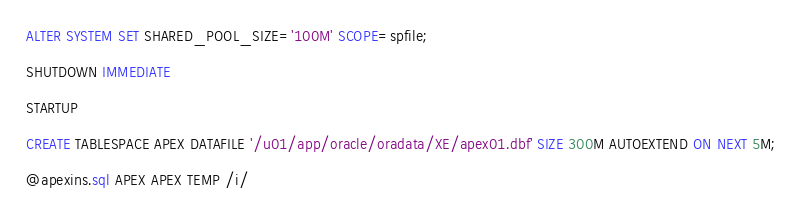Convert code to text. <code><loc_0><loc_0><loc_500><loc_500><_SQL_>ALTER SYSTEM SET SHARED_POOL_SIZE='100M' SCOPE=spfile;

SHUTDOWN IMMEDIATE

STARTUP

CREATE TABLESPACE APEX DATAFILE '/u01/app/oracle/oradata/XE/apex01.dbf' SIZE 300M AUTOEXTEND ON NEXT 5M;

@apexins.sql APEX APEX TEMP /i/</code> 